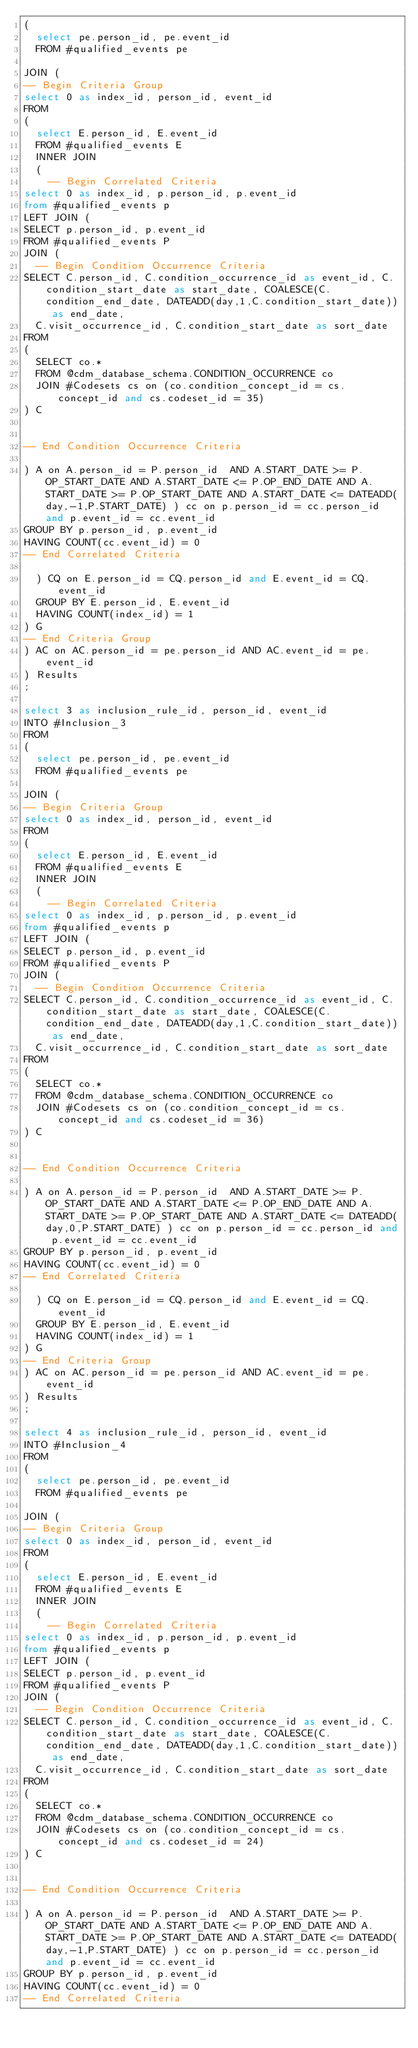Convert code to text. <code><loc_0><loc_0><loc_500><loc_500><_SQL_>(
  select pe.person_id, pe.event_id
  FROM #qualified_events pe
  
JOIN (
-- Begin Criteria Group
select 0 as index_id, person_id, event_id
FROM
(
  select E.person_id, E.event_id 
  FROM #qualified_events E
  INNER JOIN
  (
    -- Begin Correlated Criteria
select 0 as index_id, p.person_id, p.event_id
from #qualified_events p
LEFT JOIN (
SELECT p.person_id, p.event_id 
FROM #qualified_events P
JOIN (
  -- Begin Condition Occurrence Criteria
SELECT C.person_id, C.condition_occurrence_id as event_id, C.condition_start_date as start_date, COALESCE(C.condition_end_date, DATEADD(day,1,C.condition_start_date)) as end_date,
  C.visit_occurrence_id, C.condition_start_date as sort_date
FROM 
(
  SELECT co.* 
  FROM @cdm_database_schema.CONDITION_OCCURRENCE co
  JOIN #Codesets cs on (co.condition_concept_id = cs.concept_id and cs.codeset_id = 35)
) C


-- End Condition Occurrence Criteria

) A on A.person_id = P.person_id  AND A.START_DATE >= P.OP_START_DATE AND A.START_DATE <= P.OP_END_DATE AND A.START_DATE >= P.OP_START_DATE AND A.START_DATE <= DATEADD(day,-1,P.START_DATE) ) cc on p.person_id = cc.person_id and p.event_id = cc.event_id
GROUP BY p.person_id, p.event_id
HAVING COUNT(cc.event_id) = 0
-- End Correlated Criteria

  ) CQ on E.person_id = CQ.person_id and E.event_id = CQ.event_id
  GROUP BY E.person_id, E.event_id
  HAVING COUNT(index_id) = 1
) G
-- End Criteria Group
) AC on AC.person_id = pe.person_id AND AC.event_id = pe.event_id
) Results
;

select 3 as inclusion_rule_id, person_id, event_id
INTO #Inclusion_3
FROM 
(
  select pe.person_id, pe.event_id
  FROM #qualified_events pe
  
JOIN (
-- Begin Criteria Group
select 0 as index_id, person_id, event_id
FROM
(
  select E.person_id, E.event_id 
  FROM #qualified_events E
  INNER JOIN
  (
    -- Begin Correlated Criteria
select 0 as index_id, p.person_id, p.event_id
from #qualified_events p
LEFT JOIN (
SELECT p.person_id, p.event_id 
FROM #qualified_events P
JOIN (
  -- Begin Condition Occurrence Criteria
SELECT C.person_id, C.condition_occurrence_id as event_id, C.condition_start_date as start_date, COALESCE(C.condition_end_date, DATEADD(day,1,C.condition_start_date)) as end_date,
  C.visit_occurrence_id, C.condition_start_date as sort_date
FROM 
(
  SELECT co.* 
  FROM @cdm_database_schema.CONDITION_OCCURRENCE co
  JOIN #Codesets cs on (co.condition_concept_id = cs.concept_id and cs.codeset_id = 36)
) C


-- End Condition Occurrence Criteria

) A on A.person_id = P.person_id  AND A.START_DATE >= P.OP_START_DATE AND A.START_DATE <= P.OP_END_DATE AND A.START_DATE >= P.OP_START_DATE AND A.START_DATE <= DATEADD(day,0,P.START_DATE) ) cc on p.person_id = cc.person_id and p.event_id = cc.event_id
GROUP BY p.person_id, p.event_id
HAVING COUNT(cc.event_id) = 0
-- End Correlated Criteria

  ) CQ on E.person_id = CQ.person_id and E.event_id = CQ.event_id
  GROUP BY E.person_id, E.event_id
  HAVING COUNT(index_id) = 1
) G
-- End Criteria Group
) AC on AC.person_id = pe.person_id AND AC.event_id = pe.event_id
) Results
;

select 4 as inclusion_rule_id, person_id, event_id
INTO #Inclusion_4
FROM 
(
  select pe.person_id, pe.event_id
  FROM #qualified_events pe
  
JOIN (
-- Begin Criteria Group
select 0 as index_id, person_id, event_id
FROM
(
  select E.person_id, E.event_id 
  FROM #qualified_events E
  INNER JOIN
  (
    -- Begin Correlated Criteria
select 0 as index_id, p.person_id, p.event_id
from #qualified_events p
LEFT JOIN (
SELECT p.person_id, p.event_id 
FROM #qualified_events P
JOIN (
  -- Begin Condition Occurrence Criteria
SELECT C.person_id, C.condition_occurrence_id as event_id, C.condition_start_date as start_date, COALESCE(C.condition_end_date, DATEADD(day,1,C.condition_start_date)) as end_date,
  C.visit_occurrence_id, C.condition_start_date as sort_date
FROM 
(
  SELECT co.* 
  FROM @cdm_database_schema.CONDITION_OCCURRENCE co
  JOIN #Codesets cs on (co.condition_concept_id = cs.concept_id and cs.codeset_id = 24)
) C


-- End Condition Occurrence Criteria

) A on A.person_id = P.person_id  AND A.START_DATE >= P.OP_START_DATE AND A.START_DATE <= P.OP_END_DATE AND A.START_DATE >= P.OP_START_DATE AND A.START_DATE <= DATEADD(day,-1,P.START_DATE) ) cc on p.person_id = cc.person_id and p.event_id = cc.event_id
GROUP BY p.person_id, p.event_id
HAVING COUNT(cc.event_id) = 0
-- End Correlated Criteria
</code> 